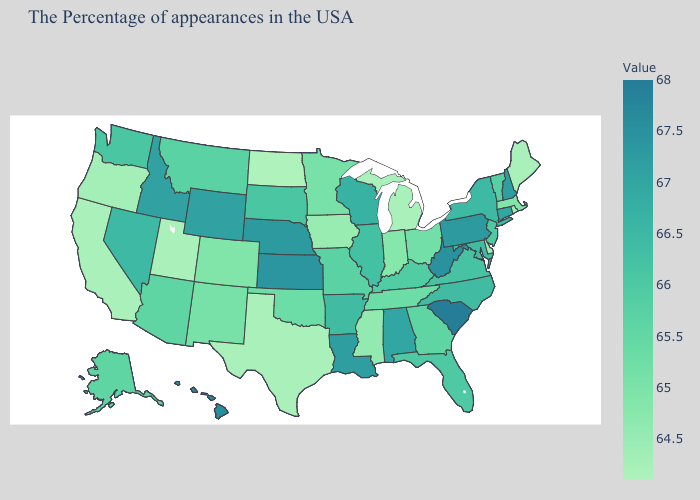Does Pennsylvania have a lower value than South Carolina?
Short answer required. Yes. Does Montana have the lowest value in the USA?
Give a very brief answer. No. Which states have the highest value in the USA?
Short answer required. South Carolina. Does North Dakota have the lowest value in the MidWest?
Concise answer only. Yes. Among the states that border Nebraska , which have the lowest value?
Be succinct. Iowa. Does Kansas have the highest value in the MidWest?
Be succinct. Yes. 